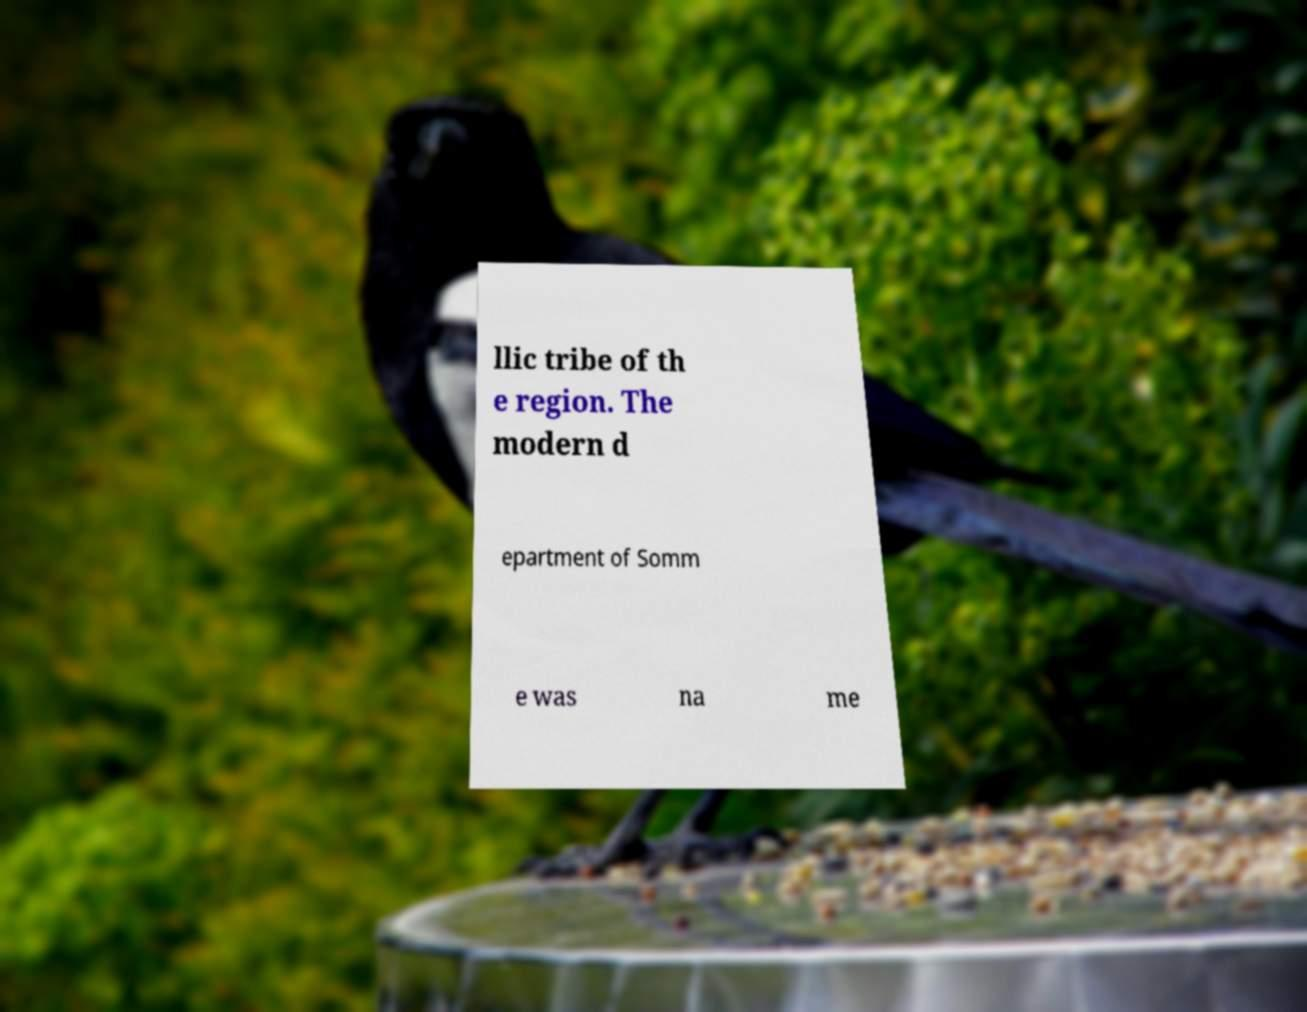What messages or text are displayed in this image? I need them in a readable, typed format. llic tribe of th e region. The modern d epartment of Somm e was na me 